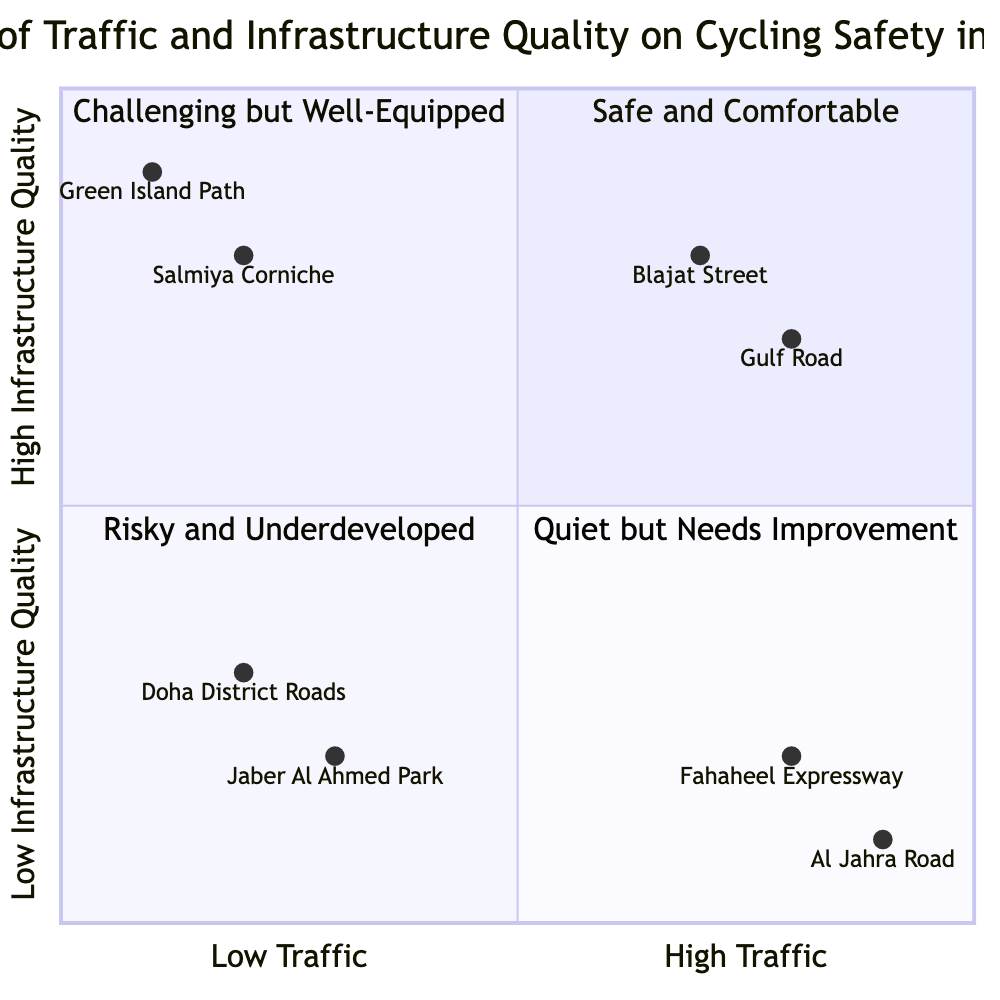What are the examples in the "Low Traffic, High Infrastructure Quality" quadrant? The "Low Traffic, High Infrastructure Quality" quadrant contains two examples: Salmiya Corniche and Green Island Path.
Answer: Salmiya Corniche, Green Island Path Which area has the highest traffic level according to the diagram? The areas with the highest traffic levels, as noted in the diagram, include Al Jahra Road and Fahaheel Expressway, both of which are located in the "High Traffic, Low Infrastructure Quality" quadrant.
Answer: Al Jahra Road, Fahaheel Expressway What is the primary characteristic of the "Risky and Underdeveloped" quadrant? The "Risky and Underdeveloped" quadrant (High Traffic, Low Infrastructure Quality) is marked by high vehicular movement and poorly maintained roads, contributing to lower safety for cyclists.
Answer: High Traffic, Low Infrastructure Quality How many areas are classified as "Challenging but Well-Equipped"? The "Challenging but Well-Equipped" quadrant has two areas represented: Gulf Road (Al Soor Street) and Blajat Street.
Answer: 2 Which area exhibits the lowest infrastructure quality? The area Jaber Al Ahmed Park is part of the "Low Traffic, Low Infrastructure Quality" quadrant, indicating it exhibits the lowest infrastructure quality according to the chart.
Answer: Jaber Al Ahmed Park Why are Fahaheel Expressway and Al Jahra Road considered risky for cyclists? Fahaheel Expressway and Al Jahra Road fall in the "High Traffic, Low Infrastructure Quality" quadrant. Their high traffic coupled with poor road conditions increases the risk for cyclists.
Answer: High traffic, poor infrastructure What defines the "High Infrastructure Quality" in this context? "High Infrastructure Quality" is defined by well-maintained roads, dedicated cycling lanes, and clear signage, providing a safer and more comfortable environment for cyclists.
Answer: Well-maintained roads, cycling lanes, clear signage In which quadrant would you find the Gulf Road? The Gulf Road is located in the "Challenging but Well-Equipped" quadrant, which corresponds to the characteristics of high traffic combined with high infrastructure quality.
Answer: Challenging but Well-Equipped 